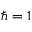Convert formula to latex. <formula><loc_0><loc_0><loc_500><loc_500>\hbar { = } 1</formula> 